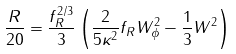<formula> <loc_0><loc_0><loc_500><loc_500>\frac { R } { 2 0 } = \frac { f _ { R } ^ { 2 / 3 } } { 3 } \left ( \frac { 2 } { 5 \kappa ^ { 2 } } f _ { R } W _ { \phi } ^ { 2 } - \frac { 1 } { 3 } W ^ { 2 } \right )</formula> 